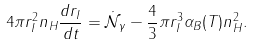Convert formula to latex. <formula><loc_0><loc_0><loc_500><loc_500>4 \pi r _ { I } ^ { 2 } n _ { H } \frac { d r _ { I } } { d t } = \dot { \mathcal { N } } _ { \gamma } - \frac { 4 } { 3 } \pi r _ { I } ^ { 3 } \alpha _ { B } ( T ) n _ { H } ^ { 2 } .</formula> 